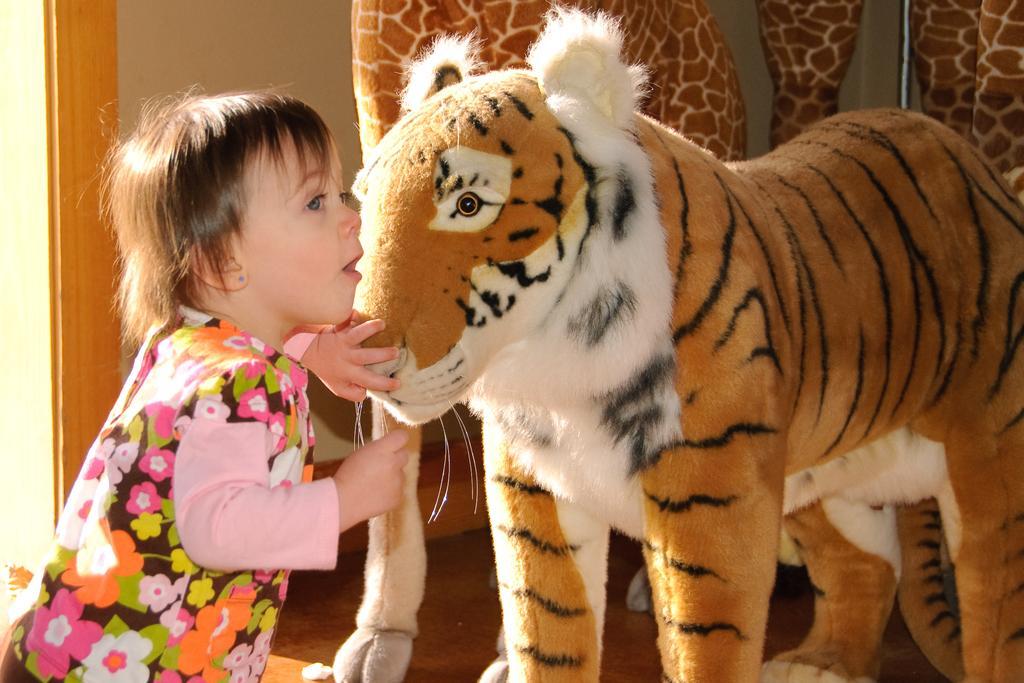Could you give a brief overview of what you see in this image? In this image I can see a kid is touching the doll tiger, this kid wore t-shirt. 